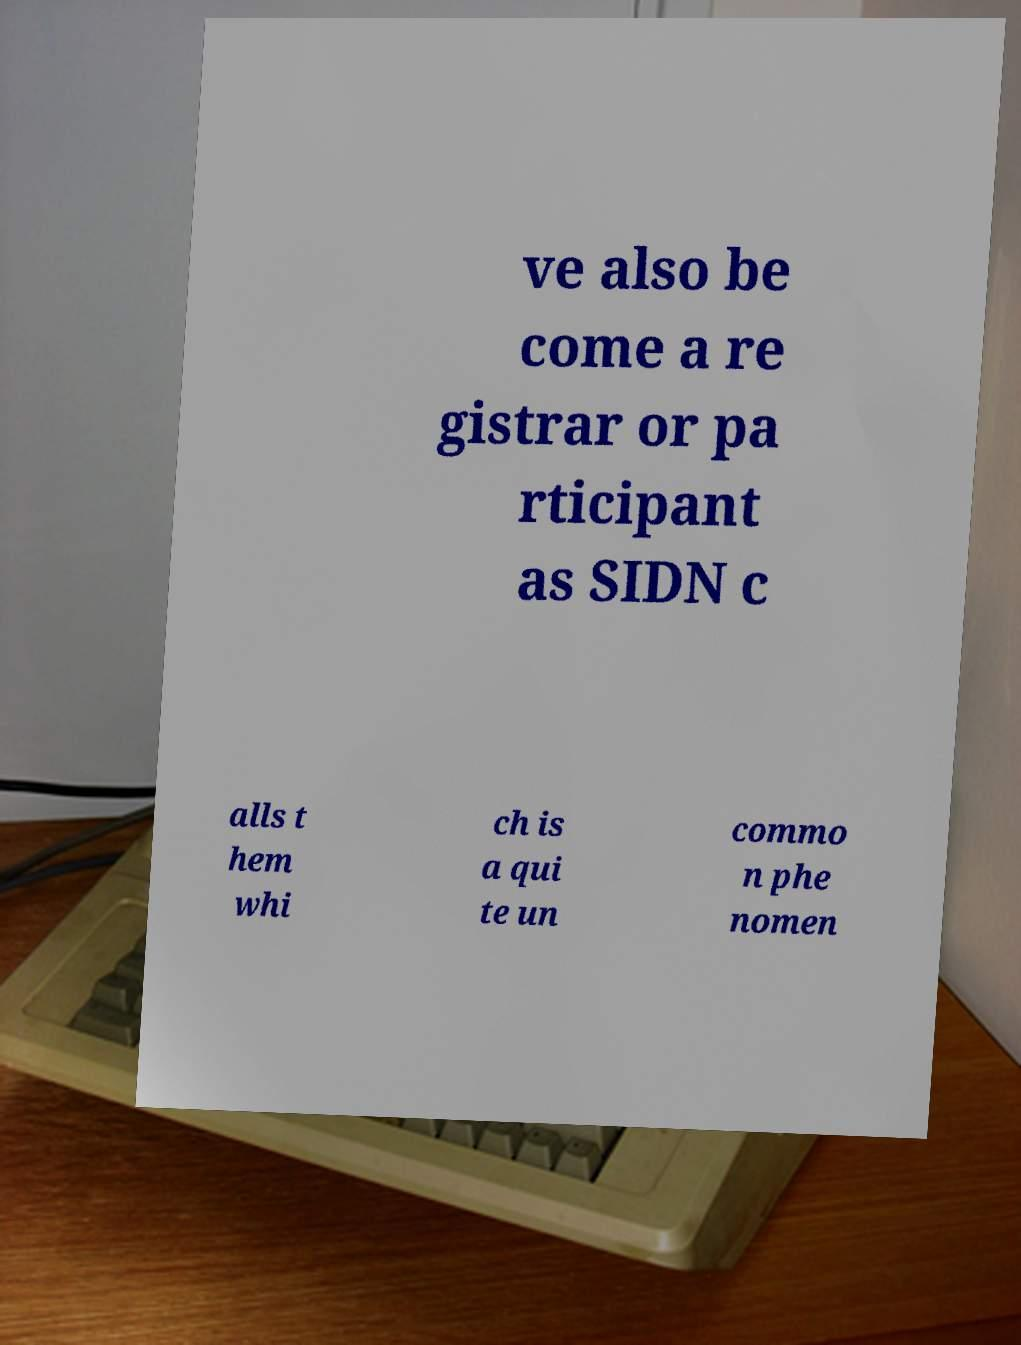Please read and relay the text visible in this image. What does it say? ve also be come a re gistrar or pa rticipant as SIDN c alls t hem whi ch is a qui te un commo n phe nomen 